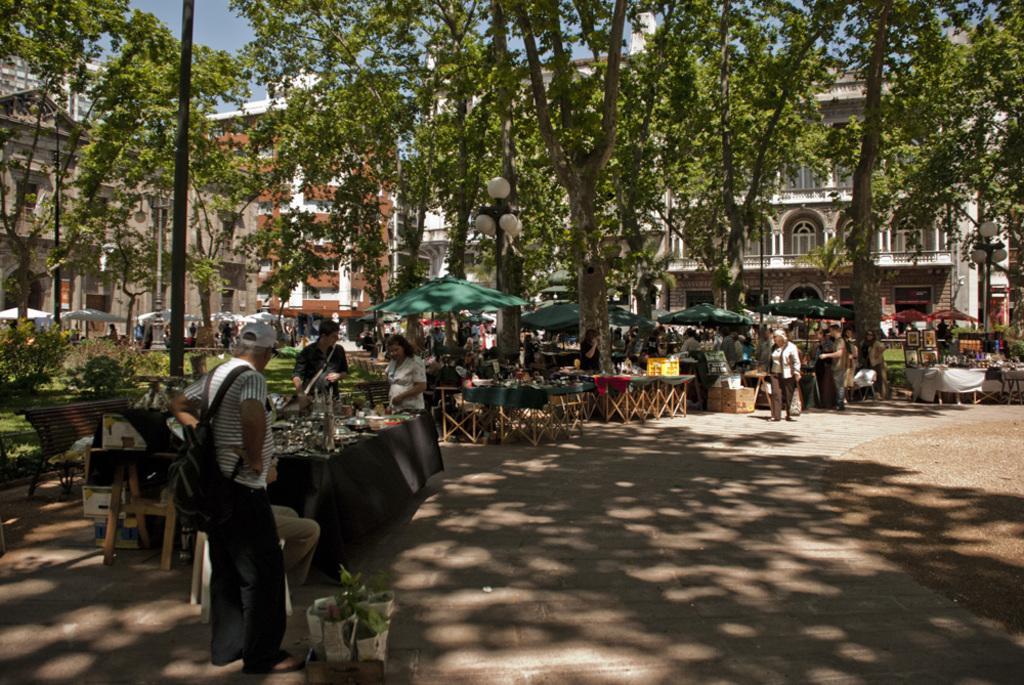Please provide a concise description of this image. On the right side of the image we can see shacks, chairs, tables and persons. On the left side of the image we can see trees, poles, shacks, tables and chairs. In the background there is a building, trees and sky. 